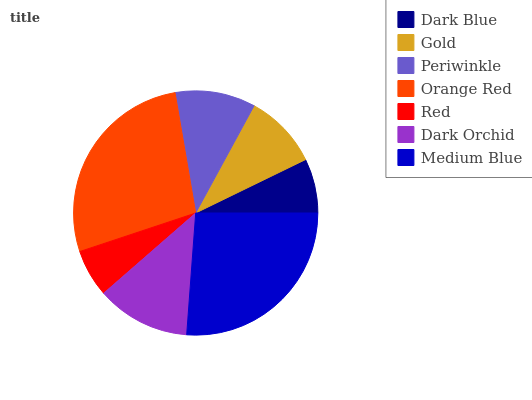Is Red the minimum?
Answer yes or no. Yes. Is Orange Red the maximum?
Answer yes or no. Yes. Is Gold the minimum?
Answer yes or no. No. Is Gold the maximum?
Answer yes or no. No. Is Gold greater than Dark Blue?
Answer yes or no. Yes. Is Dark Blue less than Gold?
Answer yes or no. Yes. Is Dark Blue greater than Gold?
Answer yes or no. No. Is Gold less than Dark Blue?
Answer yes or no. No. Is Periwinkle the high median?
Answer yes or no. Yes. Is Periwinkle the low median?
Answer yes or no. Yes. Is Medium Blue the high median?
Answer yes or no. No. Is Orange Red the low median?
Answer yes or no. No. 